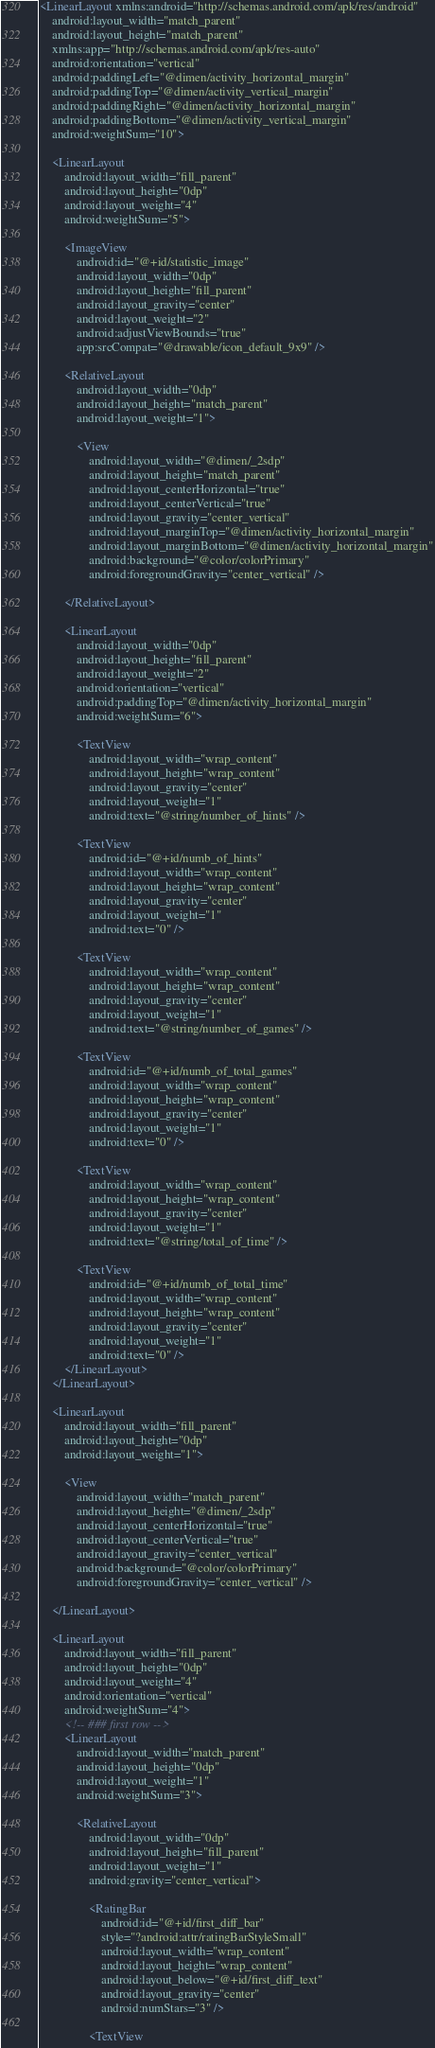Convert code to text. <code><loc_0><loc_0><loc_500><loc_500><_XML_><LinearLayout xmlns:android="http://schemas.android.com/apk/res/android"
    android:layout_width="match_parent"
    android:layout_height="match_parent"
    xmlns:app="http://schemas.android.com/apk/res-auto"
    android:orientation="vertical"
    android:paddingLeft="@dimen/activity_horizontal_margin"
    android:paddingTop="@dimen/activity_vertical_margin"
    android:paddingRight="@dimen/activity_horizontal_margin"
    android:paddingBottom="@dimen/activity_vertical_margin"
    android:weightSum="10">

    <LinearLayout
        android:layout_width="fill_parent"
        android:layout_height="0dp"
        android:layout_weight="4"
        android:weightSum="5">

        <ImageView
            android:id="@+id/statistic_image"
            android:layout_width="0dp"
            android:layout_height="fill_parent"
            android:layout_gravity="center"
            android:layout_weight="2"
            android:adjustViewBounds="true"
            app:srcCompat="@drawable/icon_default_9x9" />

        <RelativeLayout
            android:layout_width="0dp"
            android:layout_height="match_parent"
            android:layout_weight="1">

            <View
                android:layout_width="@dimen/_2sdp"
                android:layout_height="match_parent"
                android:layout_centerHorizontal="true"
                android:layout_centerVertical="true"
                android:layout_gravity="center_vertical"
                android:layout_marginTop="@dimen/activity_horizontal_margin"
                android:layout_marginBottom="@dimen/activity_horizontal_margin"
                android:background="@color/colorPrimary"
                android:foregroundGravity="center_vertical" />

        </RelativeLayout>

        <LinearLayout
            android:layout_width="0dp"
            android:layout_height="fill_parent"
            android:layout_weight="2"
            android:orientation="vertical"
            android:paddingTop="@dimen/activity_horizontal_margin"
            android:weightSum="6">

            <TextView
                android:layout_width="wrap_content"
                android:layout_height="wrap_content"
                android:layout_gravity="center"
                android:layout_weight="1"
                android:text="@string/number_of_hints" />

            <TextView
                android:id="@+id/numb_of_hints"
                android:layout_width="wrap_content"
                android:layout_height="wrap_content"
                android:layout_gravity="center"
                android:layout_weight="1"
                android:text="0" />

            <TextView
                android:layout_width="wrap_content"
                android:layout_height="wrap_content"
                android:layout_gravity="center"
                android:layout_weight="1"
                android:text="@string/number_of_games" />

            <TextView
                android:id="@+id/numb_of_total_games"
                android:layout_width="wrap_content"
                android:layout_height="wrap_content"
                android:layout_gravity="center"
                android:layout_weight="1"
                android:text="0" />

            <TextView
                android:layout_width="wrap_content"
                android:layout_height="wrap_content"
                android:layout_gravity="center"
                android:layout_weight="1"
                android:text="@string/total_of_time" />

            <TextView
                android:id="@+id/numb_of_total_time"
                android:layout_width="wrap_content"
                android:layout_height="wrap_content"
                android:layout_gravity="center"
                android:layout_weight="1"
                android:text="0" />
        </LinearLayout>
    </LinearLayout>

    <LinearLayout
        android:layout_width="fill_parent"
        android:layout_height="0dp"
        android:layout_weight="1">

        <View
            android:layout_width="match_parent"
            android:layout_height="@dimen/_2sdp"
            android:layout_centerHorizontal="true"
            android:layout_centerVertical="true"
            android:layout_gravity="center_vertical"
            android:background="@color/colorPrimary"
            android:foregroundGravity="center_vertical" />

    </LinearLayout>

    <LinearLayout
        android:layout_width="fill_parent"
        android:layout_height="0dp"
        android:layout_weight="4"
        android:orientation="vertical"
        android:weightSum="4">
        <!-- ### first row -->
        <LinearLayout
            android:layout_width="match_parent"
            android:layout_height="0dp"
            android:layout_weight="1"
            android:weightSum="3">

            <RelativeLayout
                android:layout_width="0dp"
                android:layout_height="fill_parent"
                android:layout_weight="1"
                android:gravity="center_vertical">

                <RatingBar
                    android:id="@+id/first_diff_bar"
                    style="?android:attr/ratingBarStyleSmall"
                    android:layout_width="wrap_content"
                    android:layout_height="wrap_content"
                    android:layout_below="@+id/first_diff_text"
                    android:layout_gravity="center"
                    android:numStars="3" />

                <TextView</code> 